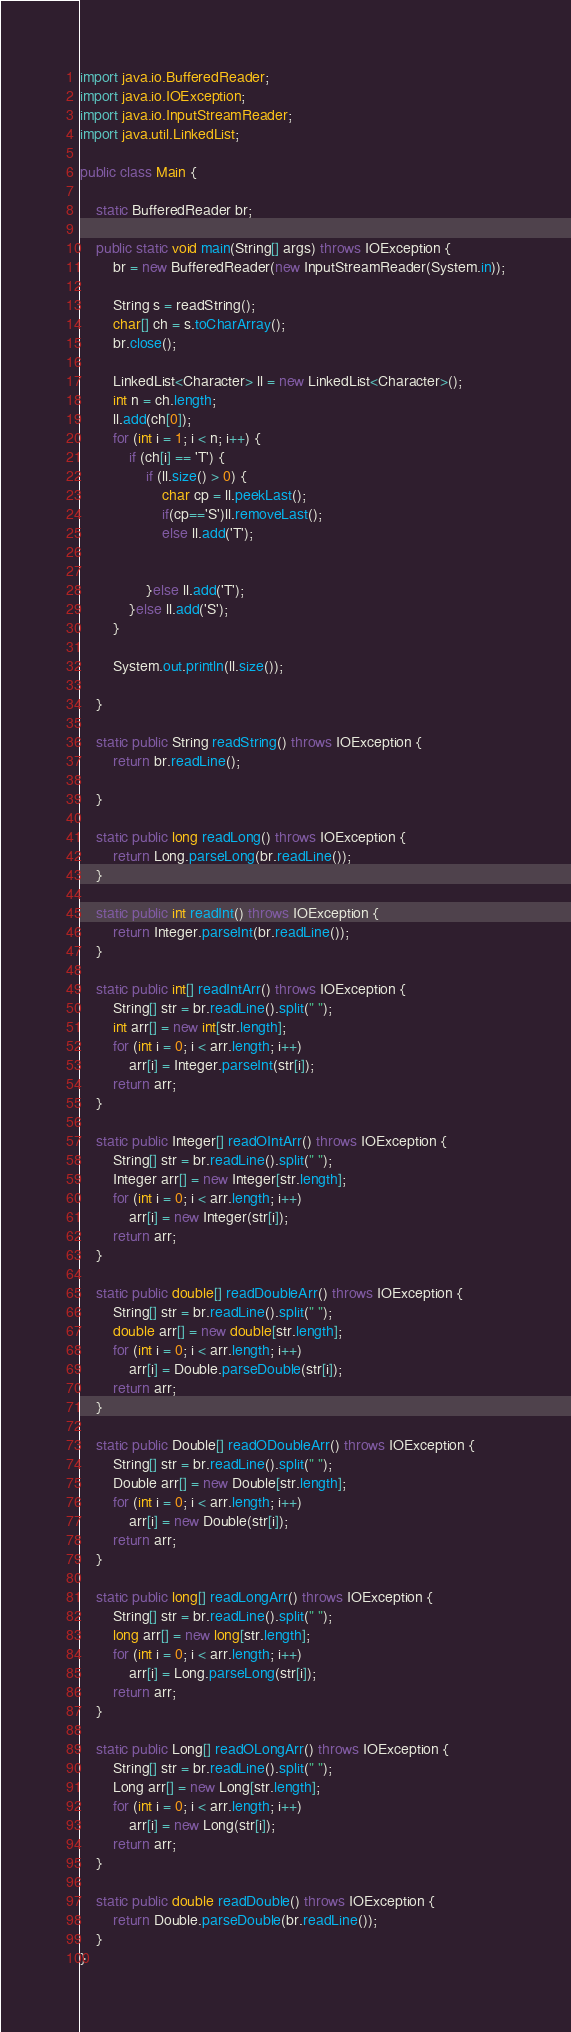Convert code to text. <code><loc_0><loc_0><loc_500><loc_500><_Java_>import java.io.BufferedReader;
import java.io.IOException;
import java.io.InputStreamReader;
import java.util.LinkedList;

public class Main {

	static BufferedReader br;

	public static void main(String[] args) throws IOException {
		br = new BufferedReader(new InputStreamReader(System.in));

		String s = readString();
		char[] ch = s.toCharArray();
		br.close();

		LinkedList<Character> ll = new LinkedList<Character>();
		int n = ch.length;
		ll.add(ch[0]);
		for (int i = 1; i < n; i++) {
			if (ch[i] == 'T') {
				if (ll.size() > 0) {
					char cp = ll.peekLast();
					if(cp=='S')ll.removeLast();
					else ll.add('T');
				

				}else ll.add('T');
			}else ll.add('S');
		}
		
		System.out.println(ll.size());

	}

	static public String readString() throws IOException {
		return br.readLine();

	}

	static public long readLong() throws IOException {
		return Long.parseLong(br.readLine());
	}

	static public int readInt() throws IOException {
		return Integer.parseInt(br.readLine());
	}

	static public int[] readIntArr() throws IOException {
		String[] str = br.readLine().split(" ");
		int arr[] = new int[str.length];
		for (int i = 0; i < arr.length; i++)
			arr[i] = Integer.parseInt(str[i]);
		return arr;
	}

	static public Integer[] readOIntArr() throws IOException {
		String[] str = br.readLine().split(" ");
		Integer arr[] = new Integer[str.length];
		for (int i = 0; i < arr.length; i++)
			arr[i] = new Integer(str[i]);
		return arr;
	}

	static public double[] readDoubleArr() throws IOException {
		String[] str = br.readLine().split(" ");
		double arr[] = new double[str.length];
		for (int i = 0; i < arr.length; i++)
			arr[i] = Double.parseDouble(str[i]);
		return arr;
	}

	static public Double[] readODoubleArr() throws IOException {
		String[] str = br.readLine().split(" ");
		Double arr[] = new Double[str.length];
		for (int i = 0; i < arr.length; i++)
			arr[i] = new Double(str[i]);
		return arr;
	}

	static public long[] readLongArr() throws IOException {
		String[] str = br.readLine().split(" ");
		long arr[] = new long[str.length];
		for (int i = 0; i < arr.length; i++)
			arr[i] = Long.parseLong(str[i]);
		return arr;
	}

	static public Long[] readOLongArr() throws IOException {
		String[] str = br.readLine().split(" ");
		Long arr[] = new Long[str.length];
		for (int i = 0; i < arr.length; i++)
			arr[i] = new Long(str[i]);
		return arr;
	}

	static public double readDouble() throws IOException {
		return Double.parseDouble(br.readLine());
	}
}
</code> 